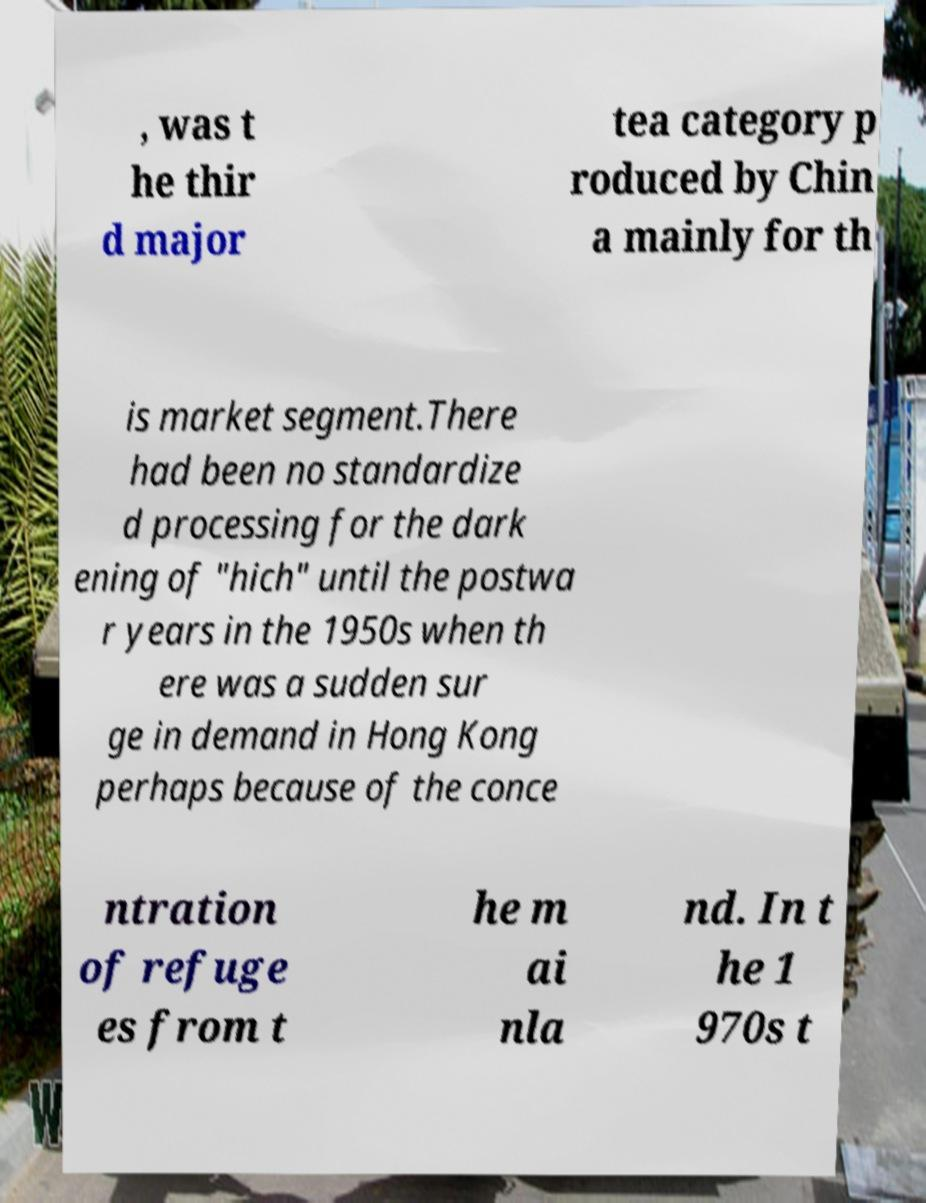What messages or text are displayed in this image? I need them in a readable, typed format. , was t he thir d major tea category p roduced by Chin a mainly for th is market segment.There had been no standardize d processing for the dark ening of "hich" until the postwa r years in the 1950s when th ere was a sudden sur ge in demand in Hong Kong perhaps because of the conce ntration of refuge es from t he m ai nla nd. In t he 1 970s t 